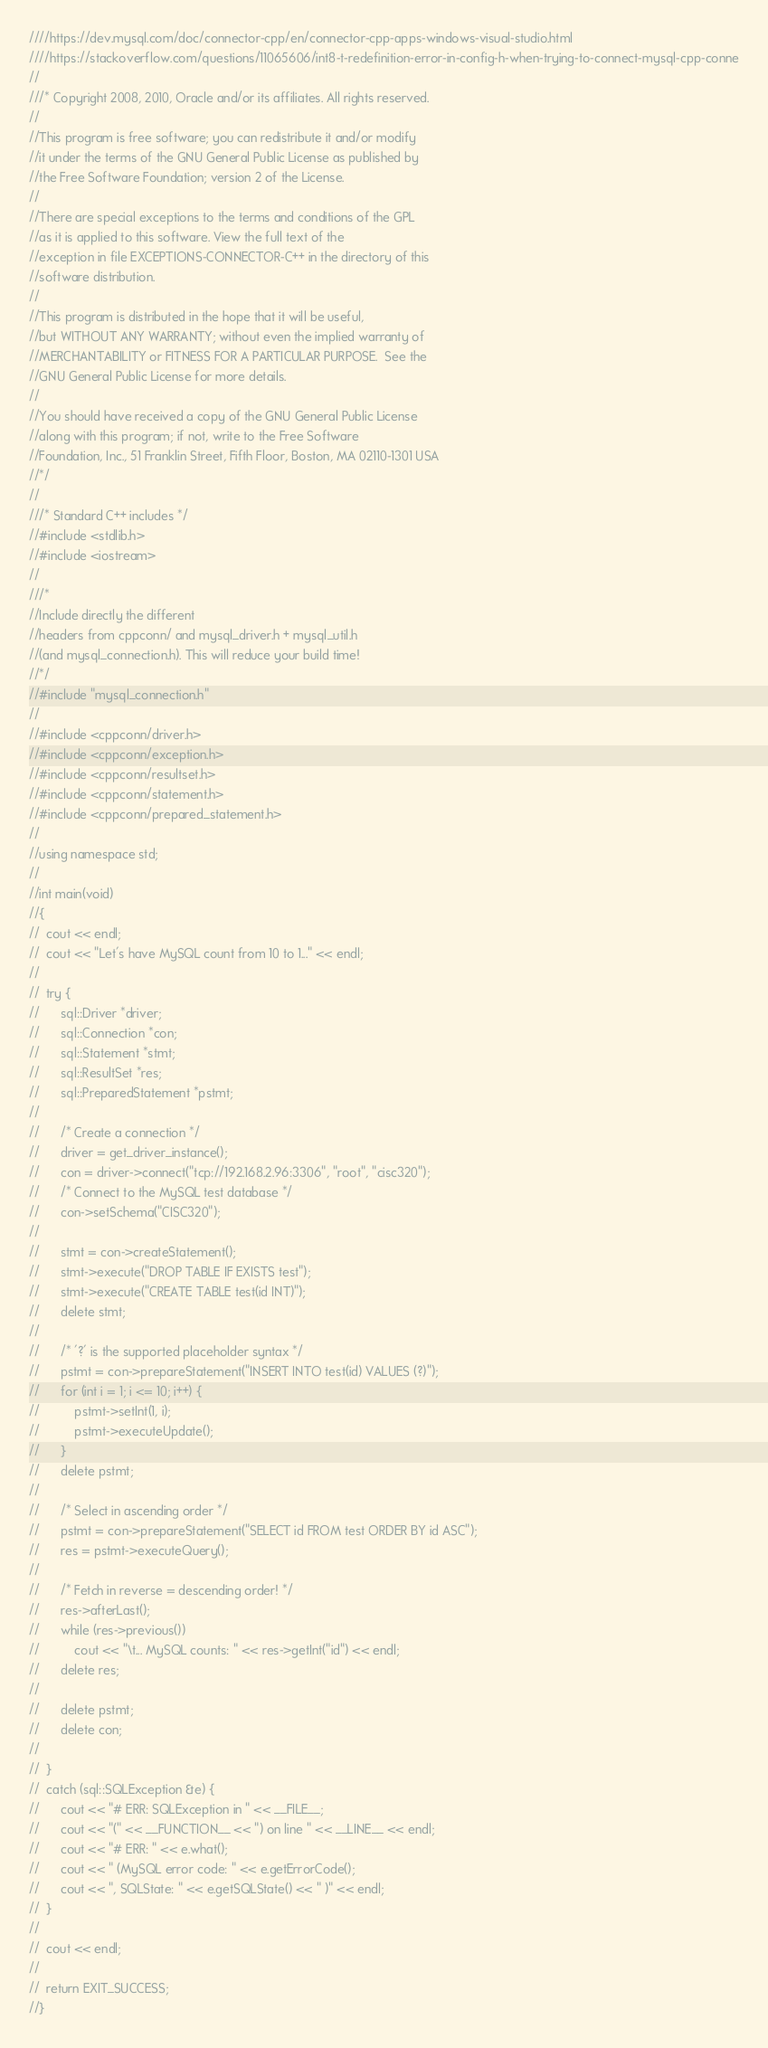<code> <loc_0><loc_0><loc_500><loc_500><_C++_>////https://dev.mysql.com/doc/connector-cpp/en/connector-cpp-apps-windows-visual-studio.html
////https://stackoverflow.com/questions/11065606/int8-t-redefinition-error-in-config-h-when-trying-to-connect-mysql-cpp-conne
//
///* Copyright 2008, 2010, Oracle and/or its affiliates. All rights reserved.
//
//This program is free software; you can redistribute it and/or modify
//it under the terms of the GNU General Public License as published by
//the Free Software Foundation; version 2 of the License.
//
//There are special exceptions to the terms and conditions of the GPL
//as it is applied to this software. View the full text of the
//exception in file EXCEPTIONS-CONNECTOR-C++ in the directory of this
//software distribution.
//
//This program is distributed in the hope that it will be useful,
//but WITHOUT ANY WARRANTY; without even the implied warranty of
//MERCHANTABILITY or FITNESS FOR A PARTICULAR PURPOSE.  See the
//GNU General Public License for more details.
//
//You should have received a copy of the GNU General Public License
//along with this program; if not, write to the Free Software
//Foundation, Inc., 51 Franklin Street, Fifth Floor, Boston, MA 02110-1301 USA
//*/
//
///* Standard C++ includes */
//#include <stdlib.h>
//#include <iostream>
//
///*
//Include directly the different
//headers from cppconn/ and mysql_driver.h + mysql_util.h
//(and mysql_connection.h). This will reduce your build time!
//*/
//#include "mysql_connection.h"
//
//#include <cppconn/driver.h>
//#include <cppconn/exception.h>
//#include <cppconn/resultset.h>
//#include <cppconn/statement.h>
//#include <cppconn/prepared_statement.h>
//
//using namespace std;
//
//int main(void)
//{
//	cout << endl;
//	cout << "Let's have MySQL count from 10 to 1..." << endl;
//
//	try {
//		sql::Driver *driver;
//		sql::Connection *con;
//		sql::Statement *stmt;
//		sql::ResultSet *res;
//		sql::PreparedStatement *pstmt;
//
//		/* Create a connection */
//		driver = get_driver_instance();
//		con = driver->connect("tcp://192.168.2.96:3306", "root", "cisc320");
//		/* Connect to the MySQL test database */
//		con->setSchema("CISC320");
//
//		stmt = con->createStatement();
//		stmt->execute("DROP TABLE IF EXISTS test");
//		stmt->execute("CREATE TABLE test(id INT)");
//		delete stmt;
//
//		/* '?' is the supported placeholder syntax */
//		pstmt = con->prepareStatement("INSERT INTO test(id) VALUES (?)");
//		for (int i = 1; i <= 10; i++) {
//			pstmt->setInt(1, i);
//			pstmt->executeUpdate();
//		}
//		delete pstmt;
//
//		/* Select in ascending order */
//		pstmt = con->prepareStatement("SELECT id FROM test ORDER BY id ASC");
//		res = pstmt->executeQuery();
//
//		/* Fetch in reverse = descending order! */
//		res->afterLast();
//		while (res->previous())
//			cout << "\t... MySQL counts: " << res->getInt("id") << endl;
//		delete res;
//
//		delete pstmt;
//		delete con;
//
//	}
//	catch (sql::SQLException &e) {
//		cout << "# ERR: SQLException in " << __FILE__;
//		cout << "(" << __FUNCTION__ << ") on line " << __LINE__ << endl;
//		cout << "# ERR: " << e.what();
//		cout << " (MySQL error code: " << e.getErrorCode();
//		cout << ", SQLState: " << e.getSQLState() << " )" << endl;
//	}
//
//	cout << endl;
//
//	return EXIT_SUCCESS;
//}</code> 